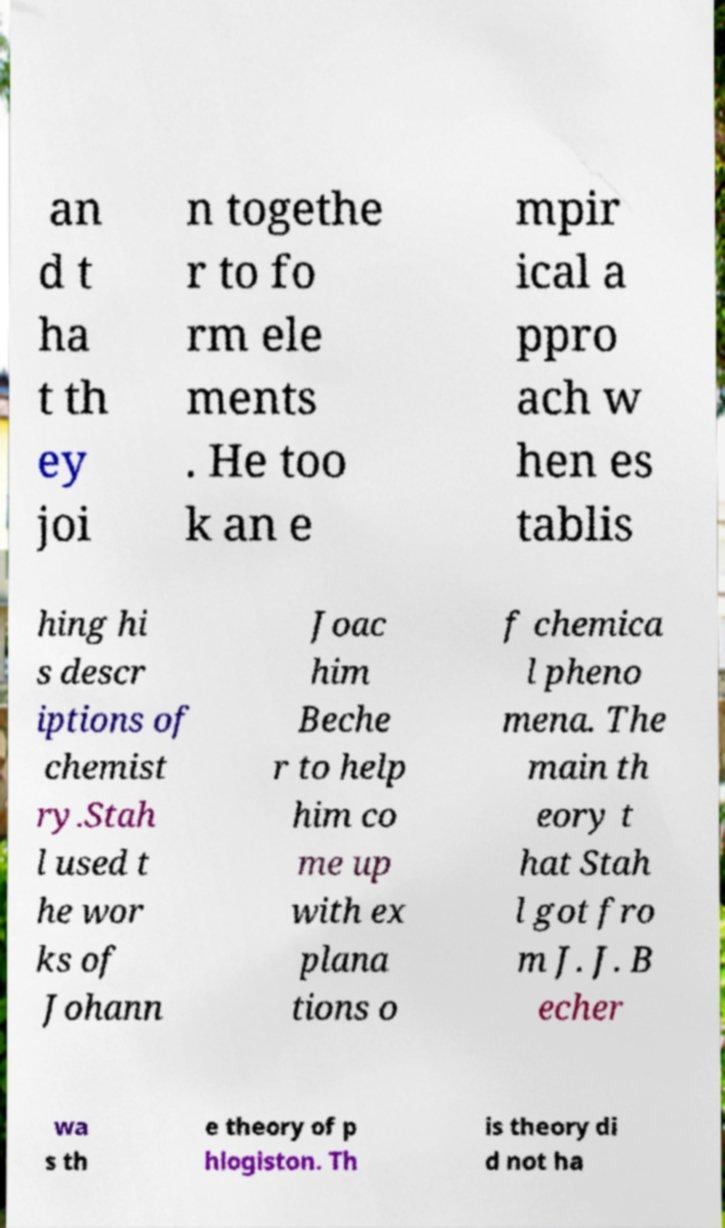Can you read and provide the text displayed in the image?This photo seems to have some interesting text. Can you extract and type it out for me? an d t ha t th ey joi n togethe r to fo rm ele ments . He too k an e mpir ical a ppro ach w hen es tablis hing hi s descr iptions of chemist ry.Stah l used t he wor ks of Johann Joac him Beche r to help him co me up with ex plana tions o f chemica l pheno mena. The main th eory t hat Stah l got fro m J. J. B echer wa s th e theory of p hlogiston. Th is theory di d not ha 